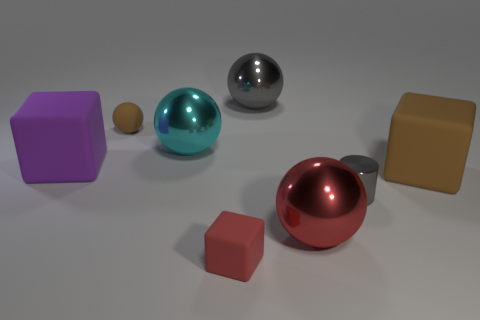Does the red thing that is right of the small red cube have the same size as the gray metal thing to the left of the gray cylinder?
Your response must be concise. Yes. What number of things are either red shiny spheres or tiny blue things?
Offer a terse response. 1. Are there any green things that have the same shape as the big brown rubber object?
Your response must be concise. No. Is the number of small red rubber blocks less than the number of big things?
Your answer should be very brief. Yes. Do the cyan thing and the small metallic object have the same shape?
Ensure brevity in your answer.  No. What number of objects are small blue rubber cubes or small rubber objects that are in front of the big purple object?
Provide a succinct answer. 1. How many brown matte cubes are there?
Offer a very short reply. 1. Are there any cyan metallic spheres of the same size as the purple thing?
Offer a very short reply. Yes. Are there fewer matte things that are in front of the gray cylinder than small yellow shiny balls?
Your answer should be compact. No. Does the purple matte object have the same size as the red sphere?
Ensure brevity in your answer.  Yes. 